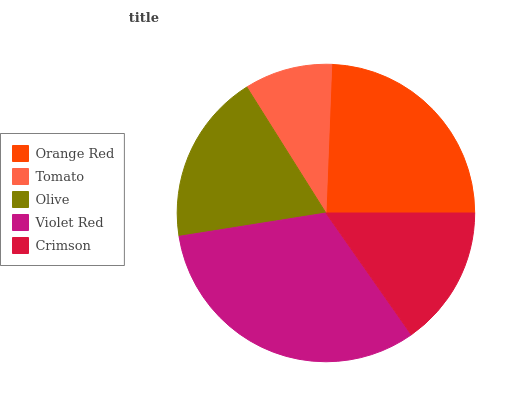Is Tomato the minimum?
Answer yes or no. Yes. Is Violet Red the maximum?
Answer yes or no. Yes. Is Olive the minimum?
Answer yes or no. No. Is Olive the maximum?
Answer yes or no. No. Is Olive greater than Tomato?
Answer yes or no. Yes. Is Tomato less than Olive?
Answer yes or no. Yes. Is Tomato greater than Olive?
Answer yes or no. No. Is Olive less than Tomato?
Answer yes or no. No. Is Olive the high median?
Answer yes or no. Yes. Is Olive the low median?
Answer yes or no. Yes. Is Tomato the high median?
Answer yes or no. No. Is Tomato the low median?
Answer yes or no. No. 